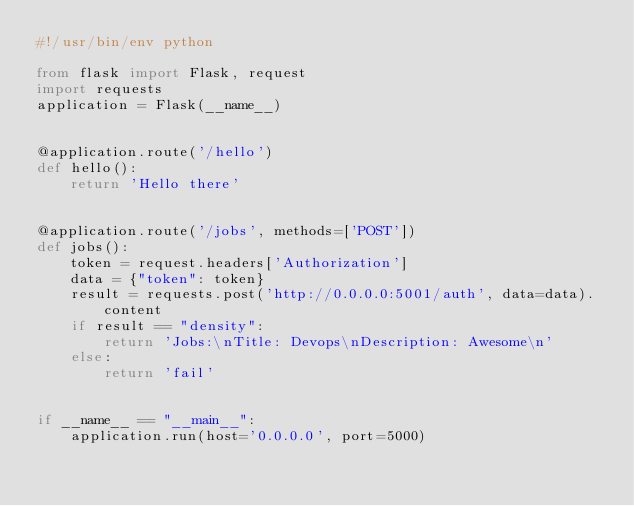Convert code to text. <code><loc_0><loc_0><loc_500><loc_500><_Python_>#!/usr/bin/env python

from flask import Flask, request
import requests
application = Flask(__name__)


@application.route('/hello')
def hello():
    return 'Hello there'


@application.route('/jobs', methods=['POST'])
def jobs():
    token = request.headers['Authorization']
    data = {"token": token}
    result = requests.post('http://0.0.0.0:5001/auth', data=data).content
    if result == "density":
        return 'Jobs:\nTitle: Devops\nDescription: Awesome\n'
    else:
        return 'fail'


if __name__ == "__main__":
    application.run(host='0.0.0.0', port=5000)
</code> 